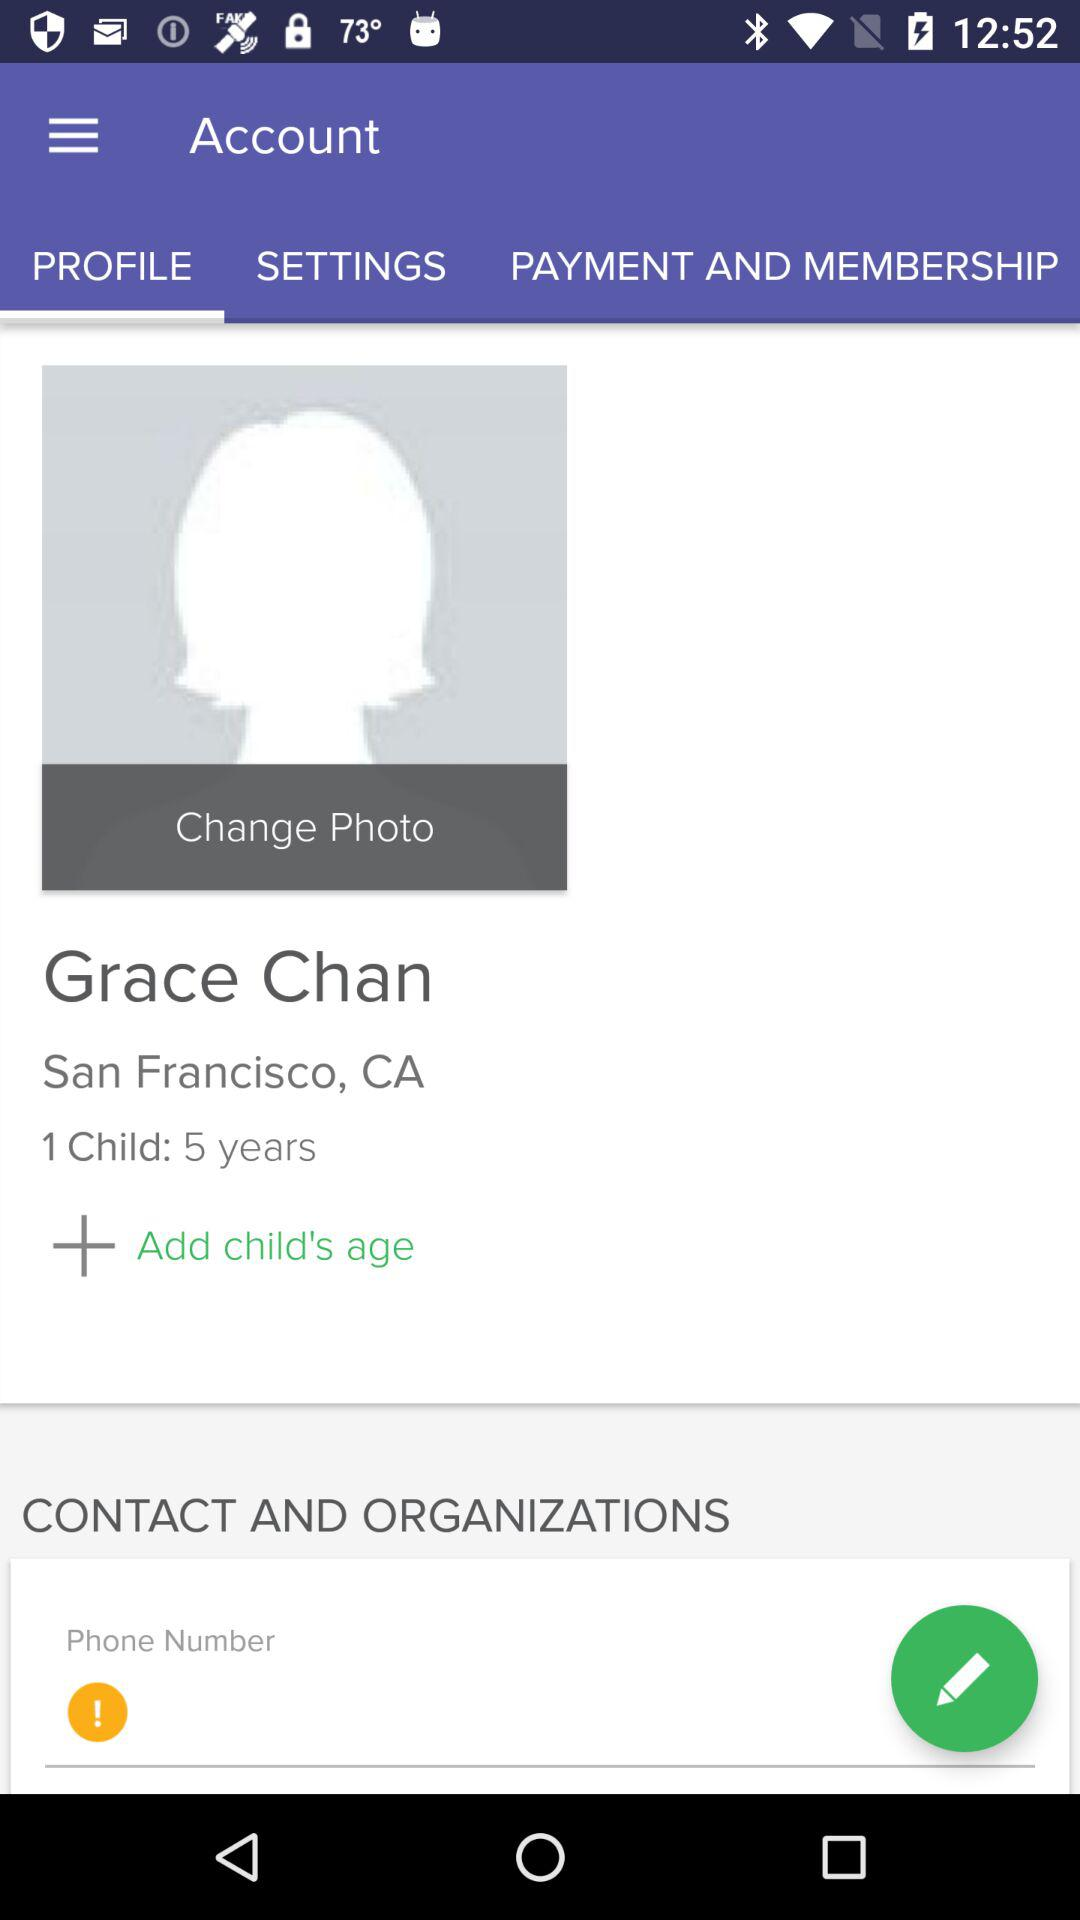How many children does Grace have? Grace has 1 child. 